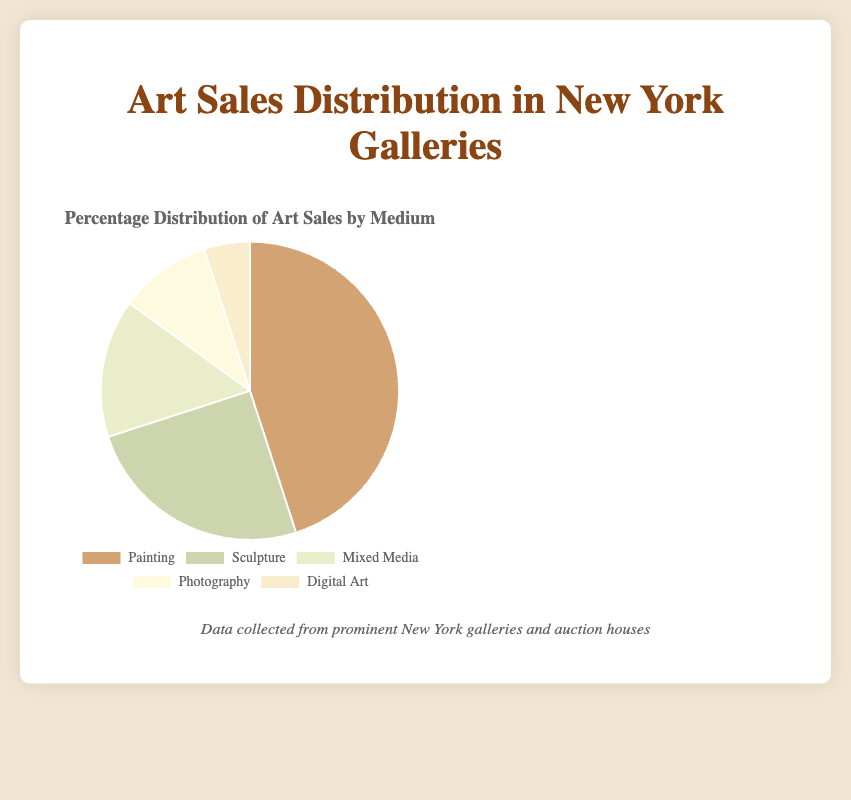What is the most popular art medium in New York galleries? By looking at the pie chart, the slice representing "Painting" is the largest, indicating it makes up the highest percentage of art sales.
Answer: Painting What is the least popular art medium in New York galleries? The smallest slice in the pie chart represents "Digital Art," indicating it has the lowest percentage of art sales.
Answer: Digital Art How much larger is the percentage of Painting sales compared to Sculpture sales? From the chart, the percentage for Painting is 45%, and for Sculpture, it is 25%. Subtracting these values gives 45% - 25% = 20%.
Answer: 20% What is the combined percentage of sales for Mixed Media and Photography? The chart shows Mixed Media at 15% and Photography at 10%. Adding these together gives 15% + 10% = 25%.
Answer: 25% Which two art mediums have the same percentage of sales, and what is that percentage? Observing the pie chart, both Photography and Digital Art have unique percentages and do not match each other. Thus, none have the same percentage.
Answer: None How do the sales percentages for Mixed Media and Photography compare? The percentage for Mixed Media is 15%, while for Photography it is 10%. Mixed Media has a higher percentage of sales than Photography.
Answer: Mixed Media > Photography If you combine the percentages for Painting and Mixed Media, what fraction of the total art sales does this represent in simplest form? Painting is 45%, and Mixed Media is 15%. Together, they are 45% + 15% = 60%. To simplify, 60% can be written as 60/100, which simplifies to 3/5.
Answer: 3/5 Which art medium has a percentage that is half of the percentage of Sculpture sales? Observing the chart, Sculpture is 25%. Half of 25% is 12.5%; however, none of the art mediums have this exact percentage.
Answer: None Which color corresponds to the medium that holds 10% of the art sales distribution? By looking at the color legend in the chart, Photography is the medium that holds 10% of the art sales, represented by a yellowish shade.
Answer: Yellow Calculate the difference in sales percentage between the highest and the lowest percentage art mediums. The highest sales percentage is for Painting at 45%, while the lowest is Digital Art at 5%. Subtracting these values gives 45% - 5% = 40%.
Answer: 40% 